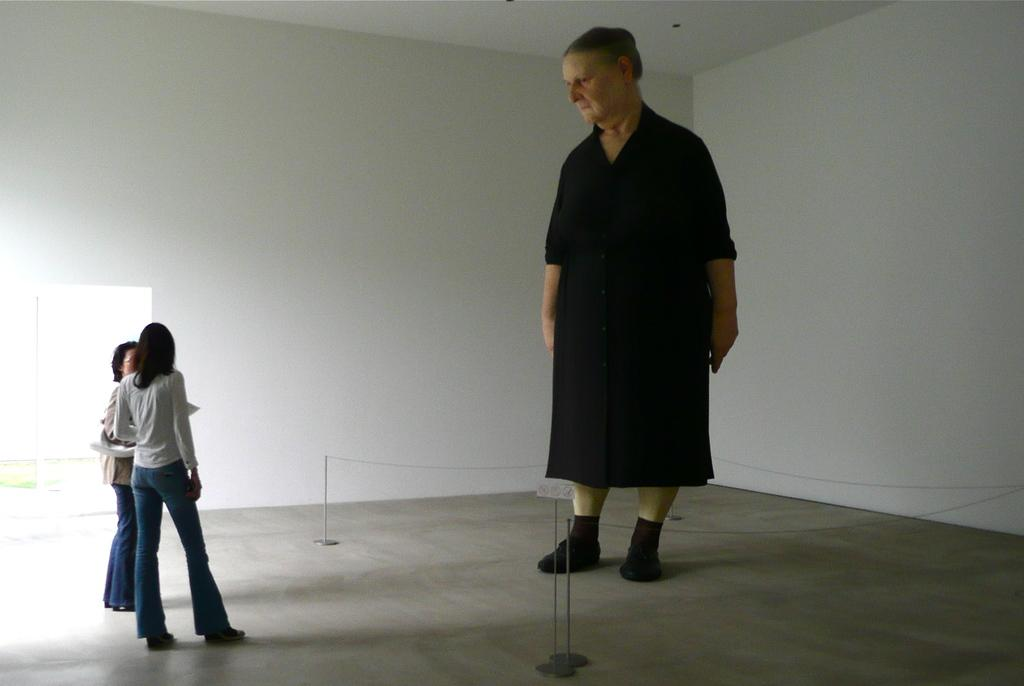What is the main subject in the room? There is a statue of a human in the room. What else can be seen in the room? There are women standing in the room. What is visible in the background of the image? There is a wall in the background of the image. What type of toe is being used to make the selection in the image? There is no selection process or toe visible in the image. 